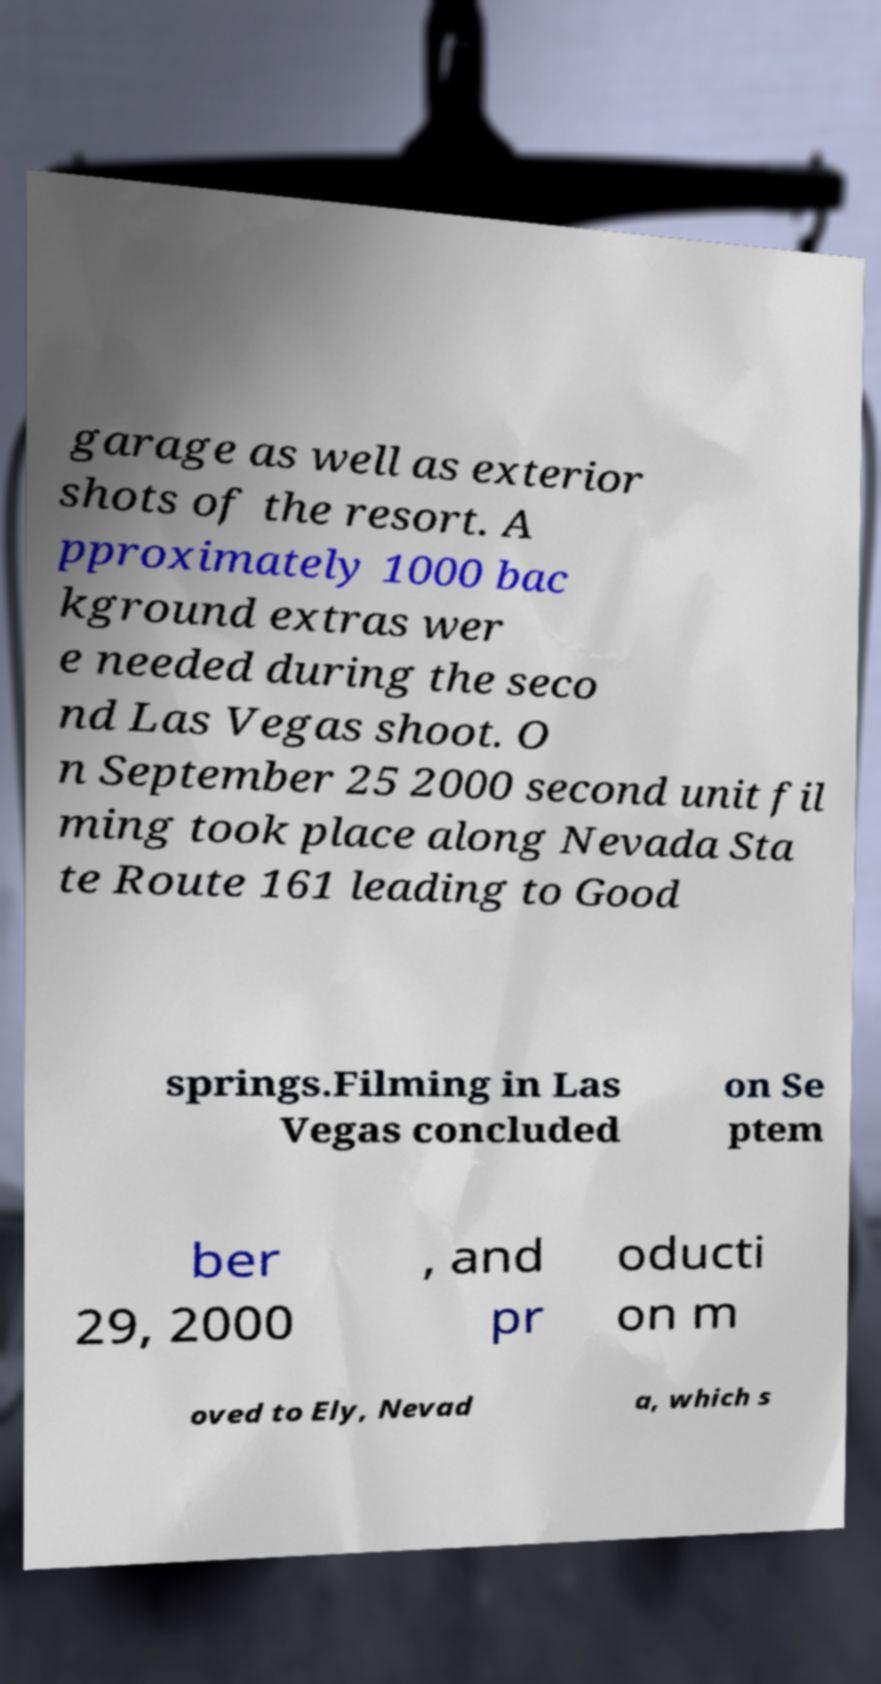Could you extract and type out the text from this image? garage as well as exterior shots of the resort. A pproximately 1000 bac kground extras wer e needed during the seco nd Las Vegas shoot. O n September 25 2000 second unit fil ming took place along Nevada Sta te Route 161 leading to Good springs.Filming in Las Vegas concluded on Se ptem ber 29, 2000 , and pr oducti on m oved to Ely, Nevad a, which s 